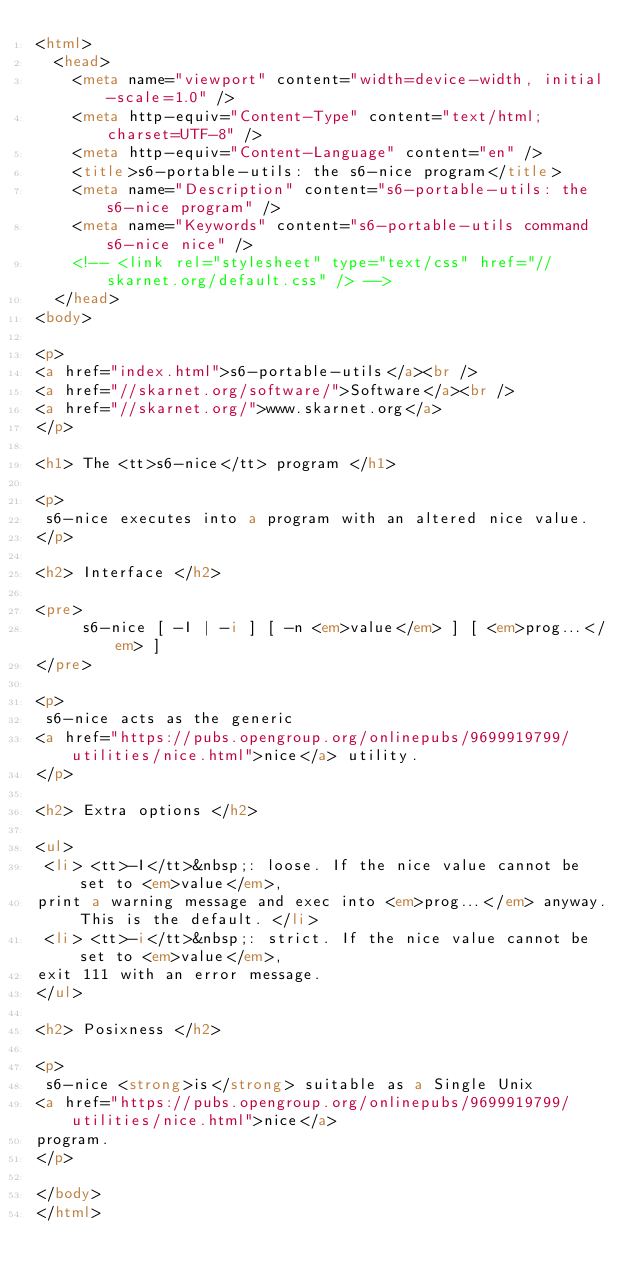Convert code to text. <code><loc_0><loc_0><loc_500><loc_500><_HTML_><html>
  <head>
    <meta name="viewport" content="width=device-width, initial-scale=1.0" />
    <meta http-equiv="Content-Type" content="text/html; charset=UTF-8" />
    <meta http-equiv="Content-Language" content="en" />
    <title>s6-portable-utils: the s6-nice program</title>
    <meta name="Description" content="s6-portable-utils: the s6-nice program" />
    <meta name="Keywords" content="s6-portable-utils command s6-nice nice" />
    <!-- <link rel="stylesheet" type="text/css" href="//skarnet.org/default.css" /> -->
  </head>
<body>

<p>
<a href="index.html">s6-portable-utils</a><br />
<a href="//skarnet.org/software/">Software</a><br />
<a href="//skarnet.org/">www.skarnet.org</a>
</p>

<h1> The <tt>s6-nice</tt> program </h1>

<p>
 s6-nice executes into a program with an altered nice value.
</p>

<h2> Interface </h2>

<pre>
     s6-nice [ -I | -i ] [ -n <em>value</em> ] [ <em>prog...</em> ]
</pre>

<p>
 s6-nice acts as the generic
<a href="https://pubs.opengroup.org/onlinepubs/9699919799/utilities/nice.html">nice</a> utility.
</p>

<h2> Extra options </h2>

<ul>
 <li> <tt>-I</tt>&nbsp;: loose. If the nice value cannot be set to <em>value</em>,
print a warning message and exec into <em>prog...</em> anyway. This is the default. </li>
 <li> <tt>-i</tt>&nbsp;: strict. If the nice value cannot be set to <em>value</em>,
exit 111 with an error message.
</ul>

<h2> Posixness </h2>

<p>
 s6-nice <strong>is</strong> suitable as a Single Unix
<a href="https://pubs.opengroup.org/onlinepubs/9699919799/utilities/nice.html">nice</a>
program.
</p>

</body>
</html>
</code> 